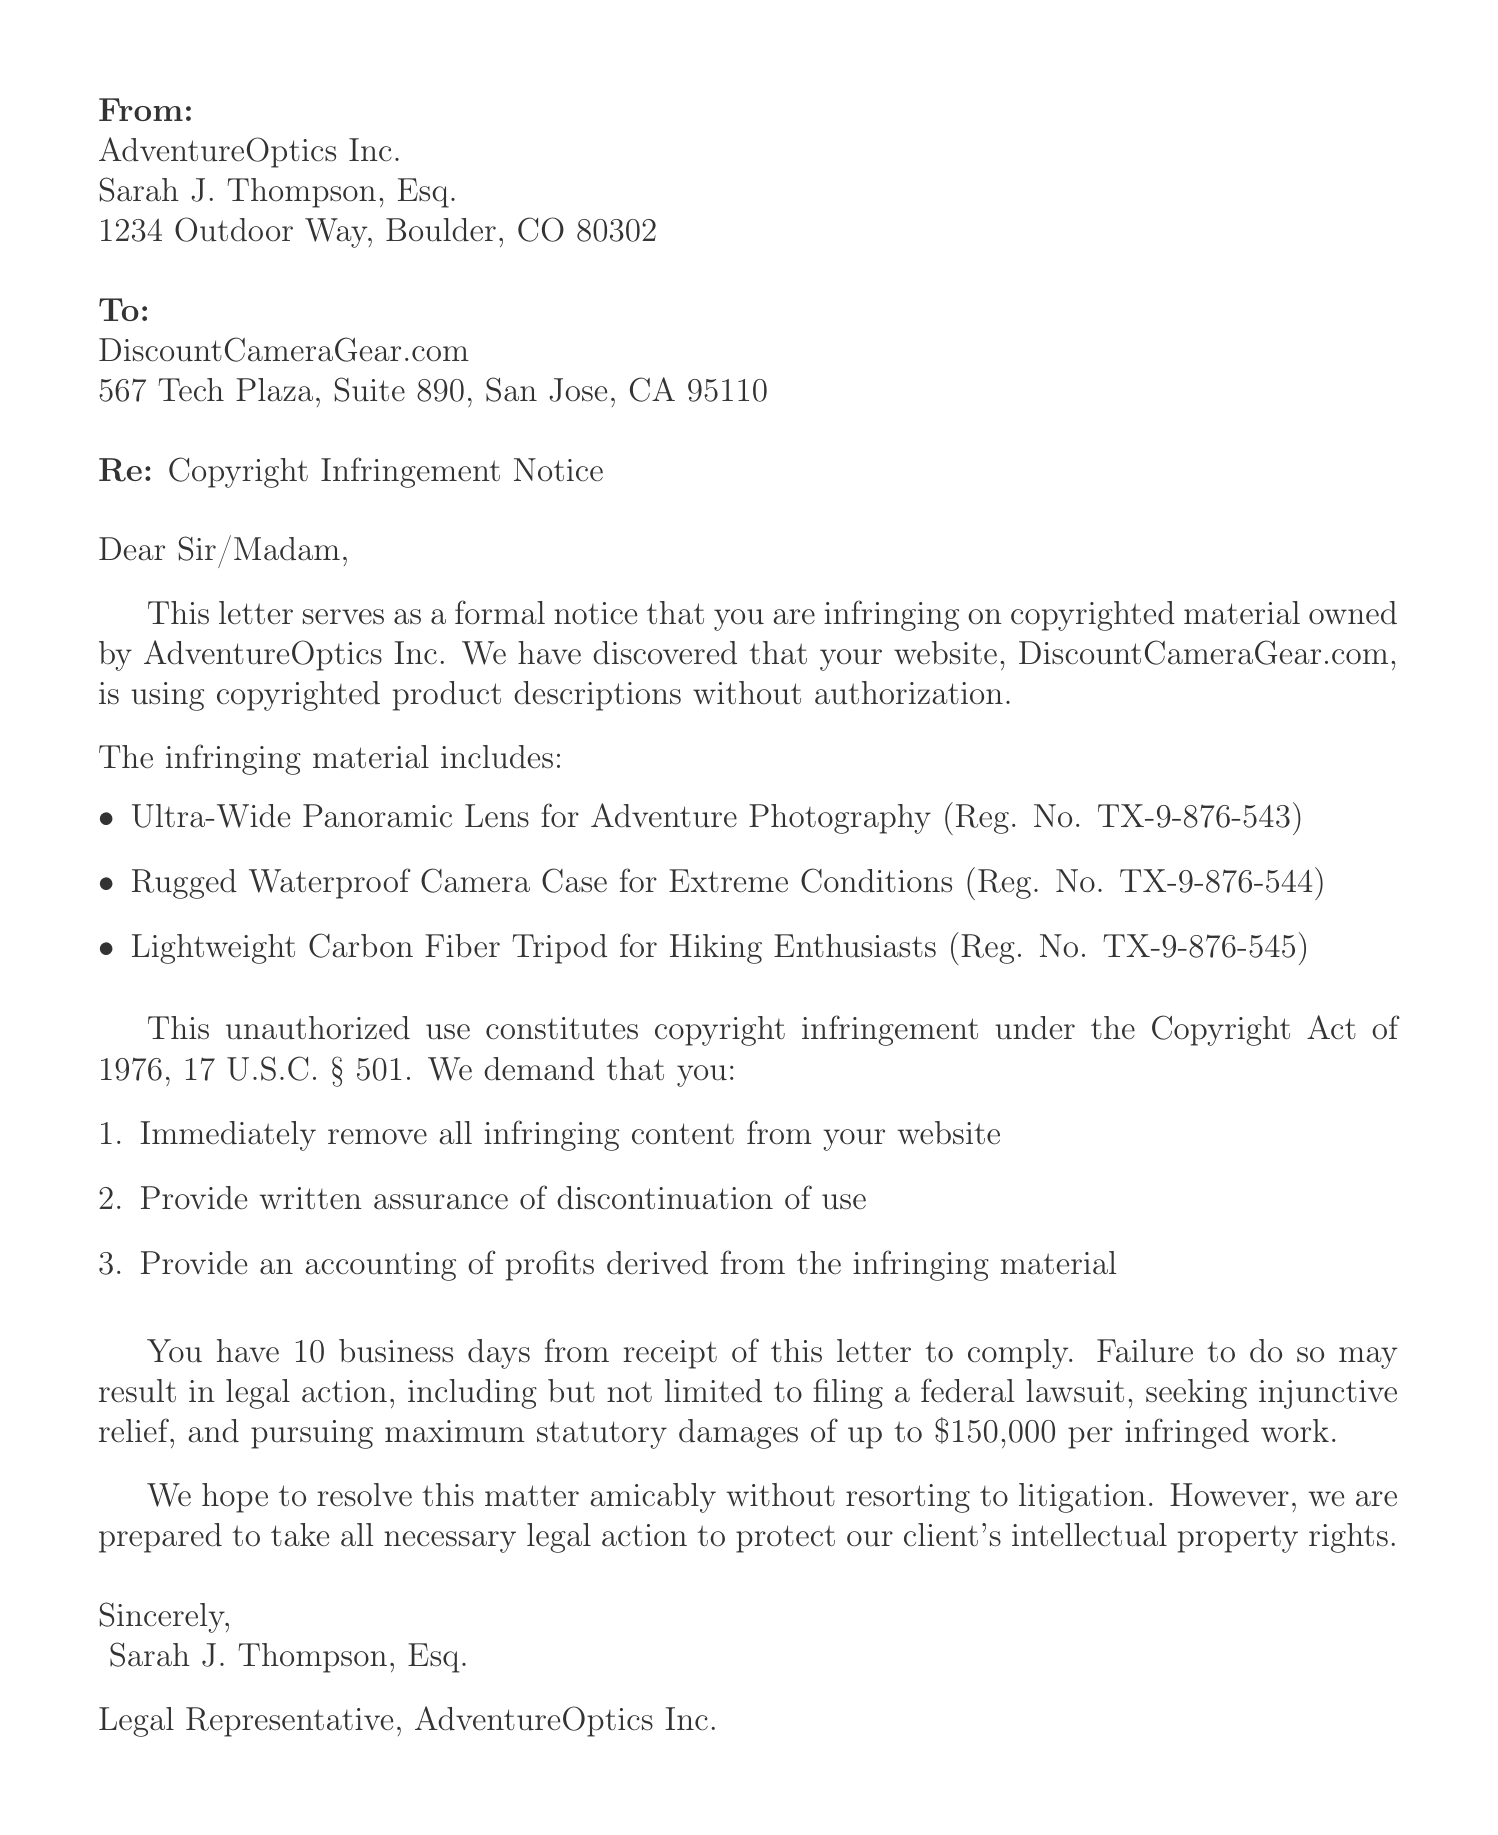What is the name of the sender company? The sender company is identified at the top of the letter as AdventureOptics Inc.
Answer: AdventureOptics Inc Who is the legal representative mentioned in the letter? The legal representative is mentioned in the sender info section of the document as Sarah J. Thompson, Esq.
Answer: Sarah J. Thompson, Esq What is the address of the recipient company? The address of the recipient company, DiscountCameraGear.com, is provided in the document.
Answer: 567 Tech Plaza, Suite 890, San Jose, CA 95110 How many business days is given for compliance? The document states a specific timeline for compliance, which is 10 business days from receipt of the letter.
Answer: 10 business days What is one of the demands made in the letter? The letter lists multiple demands, one of which is the immediate removal of infringing content from the website.
Answer: Immediate removal of infringing content from your website What are the potential consequences of non-compliance? The letter outlines several legal actions that could be taken if compliance is not met, including filing a federal lawsuit.
Answer: Filing of a federal lawsuit What is the legal basis cited for the copyright infringement? The letter refers to a specific legal statute when discussing copyright infringement.
Answer: Copyright Act of 1976, 17 U.S.C. § 501 How many product descriptions are identified as infringing? The document lists three specific product descriptions that are alleged to be infringing.
Answer: Three What are the statutory damages mentioned in the letter? The letter specifies the amount of statutory damages that could be pursued for each infringed work.
Answer: up to $150,000 per infringed work 